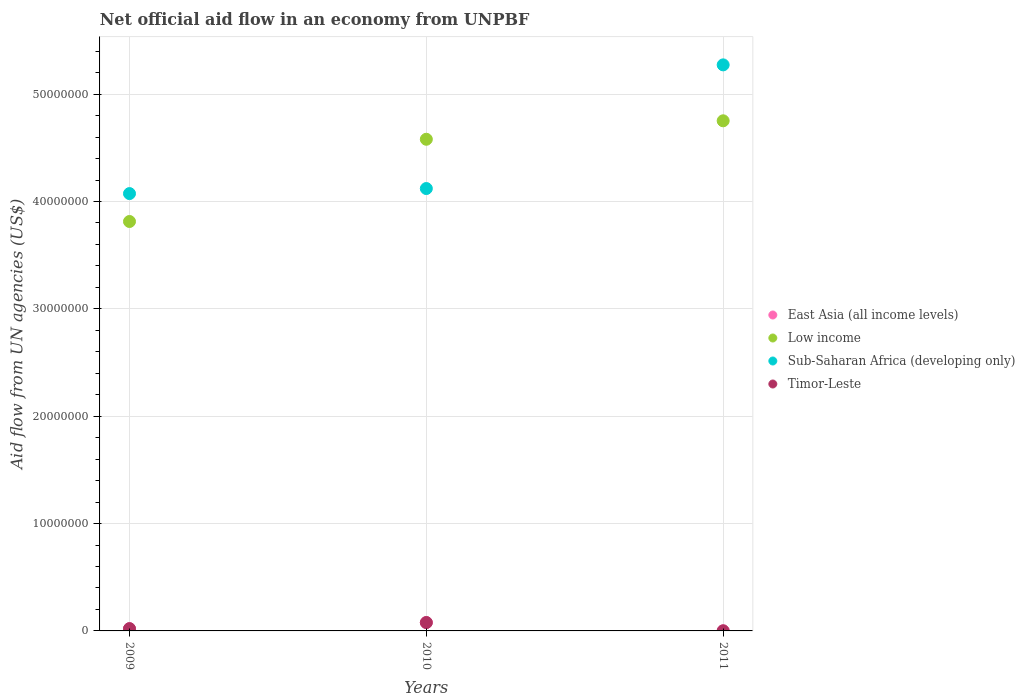How many different coloured dotlines are there?
Provide a short and direct response. 4. Is the number of dotlines equal to the number of legend labels?
Give a very brief answer. Yes. What is the net official aid flow in Sub-Saharan Africa (developing only) in 2009?
Make the answer very short. 4.07e+07. Across all years, what is the maximum net official aid flow in Low income?
Your answer should be very brief. 4.75e+07. Across all years, what is the minimum net official aid flow in Low income?
Keep it short and to the point. 3.81e+07. What is the difference between the net official aid flow in Sub-Saharan Africa (developing only) in 2010 and that in 2011?
Make the answer very short. -1.15e+07. What is the difference between the net official aid flow in Sub-Saharan Africa (developing only) in 2009 and the net official aid flow in Timor-Leste in 2010?
Make the answer very short. 4.00e+07. What is the average net official aid flow in East Asia (all income levels) per year?
Your response must be concise. 3.33e+05. In the year 2010, what is the difference between the net official aid flow in Low income and net official aid flow in Timor-Leste?
Your response must be concise. 4.50e+07. In how many years, is the net official aid flow in East Asia (all income levels) greater than 44000000 US$?
Give a very brief answer. 0. Is the net official aid flow in Timor-Leste in 2010 less than that in 2011?
Your answer should be very brief. No. Is the difference between the net official aid flow in Low income in 2010 and 2011 greater than the difference between the net official aid flow in Timor-Leste in 2010 and 2011?
Ensure brevity in your answer.  No. What is the difference between the highest and the second highest net official aid flow in Low income?
Provide a succinct answer. 1.72e+06. What is the difference between the highest and the lowest net official aid flow in East Asia (all income levels)?
Keep it short and to the point. 7.70e+05. Is the sum of the net official aid flow in East Asia (all income levels) in 2009 and 2011 greater than the maximum net official aid flow in Sub-Saharan Africa (developing only) across all years?
Your response must be concise. No. Is it the case that in every year, the sum of the net official aid flow in East Asia (all income levels) and net official aid flow in Low income  is greater than the sum of net official aid flow in Sub-Saharan Africa (developing only) and net official aid flow in Timor-Leste?
Offer a very short reply. Yes. Is it the case that in every year, the sum of the net official aid flow in East Asia (all income levels) and net official aid flow in Sub-Saharan Africa (developing only)  is greater than the net official aid flow in Low income?
Make the answer very short. No. Does the net official aid flow in Low income monotonically increase over the years?
Offer a terse response. Yes. Is the net official aid flow in East Asia (all income levels) strictly greater than the net official aid flow in Timor-Leste over the years?
Keep it short and to the point. No. Is the net official aid flow in Timor-Leste strictly less than the net official aid flow in East Asia (all income levels) over the years?
Provide a short and direct response. No. How many years are there in the graph?
Your response must be concise. 3. What is the difference between two consecutive major ticks on the Y-axis?
Offer a very short reply. 1.00e+07. Does the graph contain any zero values?
Keep it short and to the point. No. Does the graph contain grids?
Make the answer very short. Yes. What is the title of the graph?
Ensure brevity in your answer.  Net official aid flow in an economy from UNPBF. Does "Estonia" appear as one of the legend labels in the graph?
Ensure brevity in your answer.  No. What is the label or title of the X-axis?
Provide a succinct answer. Years. What is the label or title of the Y-axis?
Make the answer very short. Aid flow from UN agencies (US$). What is the Aid flow from UN agencies (US$) of Low income in 2009?
Provide a succinct answer. 3.81e+07. What is the Aid flow from UN agencies (US$) of Sub-Saharan Africa (developing only) in 2009?
Provide a short and direct response. 4.07e+07. What is the Aid flow from UN agencies (US$) in Timor-Leste in 2009?
Provide a succinct answer. 2.10e+05. What is the Aid flow from UN agencies (US$) of East Asia (all income levels) in 2010?
Offer a very short reply. 7.80e+05. What is the Aid flow from UN agencies (US$) in Low income in 2010?
Give a very brief answer. 4.58e+07. What is the Aid flow from UN agencies (US$) of Sub-Saharan Africa (developing only) in 2010?
Your response must be concise. 4.12e+07. What is the Aid flow from UN agencies (US$) in Timor-Leste in 2010?
Keep it short and to the point. 7.80e+05. What is the Aid flow from UN agencies (US$) in Low income in 2011?
Your answer should be very brief. 4.75e+07. What is the Aid flow from UN agencies (US$) of Sub-Saharan Africa (developing only) in 2011?
Your response must be concise. 5.27e+07. What is the Aid flow from UN agencies (US$) in Timor-Leste in 2011?
Your answer should be compact. 10000. Across all years, what is the maximum Aid flow from UN agencies (US$) of East Asia (all income levels)?
Ensure brevity in your answer.  7.80e+05. Across all years, what is the maximum Aid flow from UN agencies (US$) in Low income?
Provide a short and direct response. 4.75e+07. Across all years, what is the maximum Aid flow from UN agencies (US$) in Sub-Saharan Africa (developing only)?
Provide a short and direct response. 5.27e+07. Across all years, what is the maximum Aid flow from UN agencies (US$) of Timor-Leste?
Ensure brevity in your answer.  7.80e+05. Across all years, what is the minimum Aid flow from UN agencies (US$) of Low income?
Keep it short and to the point. 3.81e+07. Across all years, what is the minimum Aid flow from UN agencies (US$) in Sub-Saharan Africa (developing only)?
Keep it short and to the point. 4.07e+07. What is the total Aid flow from UN agencies (US$) of East Asia (all income levels) in the graph?
Your response must be concise. 1.00e+06. What is the total Aid flow from UN agencies (US$) of Low income in the graph?
Your answer should be very brief. 1.31e+08. What is the total Aid flow from UN agencies (US$) of Sub-Saharan Africa (developing only) in the graph?
Give a very brief answer. 1.35e+08. What is the difference between the Aid flow from UN agencies (US$) in East Asia (all income levels) in 2009 and that in 2010?
Give a very brief answer. -5.70e+05. What is the difference between the Aid flow from UN agencies (US$) in Low income in 2009 and that in 2010?
Make the answer very short. -7.66e+06. What is the difference between the Aid flow from UN agencies (US$) of Sub-Saharan Africa (developing only) in 2009 and that in 2010?
Make the answer very short. -4.70e+05. What is the difference between the Aid flow from UN agencies (US$) of Timor-Leste in 2009 and that in 2010?
Keep it short and to the point. -5.70e+05. What is the difference between the Aid flow from UN agencies (US$) of East Asia (all income levels) in 2009 and that in 2011?
Your answer should be compact. 2.00e+05. What is the difference between the Aid flow from UN agencies (US$) of Low income in 2009 and that in 2011?
Your answer should be very brief. -9.38e+06. What is the difference between the Aid flow from UN agencies (US$) of Sub-Saharan Africa (developing only) in 2009 and that in 2011?
Your response must be concise. -1.20e+07. What is the difference between the Aid flow from UN agencies (US$) in Timor-Leste in 2009 and that in 2011?
Keep it short and to the point. 2.00e+05. What is the difference between the Aid flow from UN agencies (US$) of East Asia (all income levels) in 2010 and that in 2011?
Ensure brevity in your answer.  7.70e+05. What is the difference between the Aid flow from UN agencies (US$) of Low income in 2010 and that in 2011?
Your answer should be compact. -1.72e+06. What is the difference between the Aid flow from UN agencies (US$) in Sub-Saharan Africa (developing only) in 2010 and that in 2011?
Provide a short and direct response. -1.15e+07. What is the difference between the Aid flow from UN agencies (US$) of Timor-Leste in 2010 and that in 2011?
Offer a very short reply. 7.70e+05. What is the difference between the Aid flow from UN agencies (US$) of East Asia (all income levels) in 2009 and the Aid flow from UN agencies (US$) of Low income in 2010?
Your answer should be very brief. -4.56e+07. What is the difference between the Aid flow from UN agencies (US$) in East Asia (all income levels) in 2009 and the Aid flow from UN agencies (US$) in Sub-Saharan Africa (developing only) in 2010?
Keep it short and to the point. -4.10e+07. What is the difference between the Aid flow from UN agencies (US$) of East Asia (all income levels) in 2009 and the Aid flow from UN agencies (US$) of Timor-Leste in 2010?
Offer a very short reply. -5.70e+05. What is the difference between the Aid flow from UN agencies (US$) in Low income in 2009 and the Aid flow from UN agencies (US$) in Sub-Saharan Africa (developing only) in 2010?
Offer a terse response. -3.07e+06. What is the difference between the Aid flow from UN agencies (US$) of Low income in 2009 and the Aid flow from UN agencies (US$) of Timor-Leste in 2010?
Your answer should be compact. 3.74e+07. What is the difference between the Aid flow from UN agencies (US$) in Sub-Saharan Africa (developing only) in 2009 and the Aid flow from UN agencies (US$) in Timor-Leste in 2010?
Provide a short and direct response. 4.00e+07. What is the difference between the Aid flow from UN agencies (US$) in East Asia (all income levels) in 2009 and the Aid flow from UN agencies (US$) in Low income in 2011?
Ensure brevity in your answer.  -4.73e+07. What is the difference between the Aid flow from UN agencies (US$) of East Asia (all income levels) in 2009 and the Aid flow from UN agencies (US$) of Sub-Saharan Africa (developing only) in 2011?
Your answer should be compact. -5.25e+07. What is the difference between the Aid flow from UN agencies (US$) of Low income in 2009 and the Aid flow from UN agencies (US$) of Sub-Saharan Africa (developing only) in 2011?
Provide a short and direct response. -1.46e+07. What is the difference between the Aid flow from UN agencies (US$) of Low income in 2009 and the Aid flow from UN agencies (US$) of Timor-Leste in 2011?
Give a very brief answer. 3.81e+07. What is the difference between the Aid flow from UN agencies (US$) of Sub-Saharan Africa (developing only) in 2009 and the Aid flow from UN agencies (US$) of Timor-Leste in 2011?
Your answer should be very brief. 4.07e+07. What is the difference between the Aid flow from UN agencies (US$) in East Asia (all income levels) in 2010 and the Aid flow from UN agencies (US$) in Low income in 2011?
Keep it short and to the point. -4.67e+07. What is the difference between the Aid flow from UN agencies (US$) of East Asia (all income levels) in 2010 and the Aid flow from UN agencies (US$) of Sub-Saharan Africa (developing only) in 2011?
Ensure brevity in your answer.  -5.20e+07. What is the difference between the Aid flow from UN agencies (US$) of East Asia (all income levels) in 2010 and the Aid flow from UN agencies (US$) of Timor-Leste in 2011?
Offer a very short reply. 7.70e+05. What is the difference between the Aid flow from UN agencies (US$) of Low income in 2010 and the Aid flow from UN agencies (US$) of Sub-Saharan Africa (developing only) in 2011?
Keep it short and to the point. -6.93e+06. What is the difference between the Aid flow from UN agencies (US$) in Low income in 2010 and the Aid flow from UN agencies (US$) in Timor-Leste in 2011?
Provide a short and direct response. 4.58e+07. What is the difference between the Aid flow from UN agencies (US$) of Sub-Saharan Africa (developing only) in 2010 and the Aid flow from UN agencies (US$) of Timor-Leste in 2011?
Your answer should be compact. 4.12e+07. What is the average Aid flow from UN agencies (US$) of East Asia (all income levels) per year?
Offer a very short reply. 3.33e+05. What is the average Aid flow from UN agencies (US$) in Low income per year?
Keep it short and to the point. 4.38e+07. What is the average Aid flow from UN agencies (US$) of Sub-Saharan Africa (developing only) per year?
Provide a short and direct response. 4.49e+07. What is the average Aid flow from UN agencies (US$) of Timor-Leste per year?
Your answer should be compact. 3.33e+05. In the year 2009, what is the difference between the Aid flow from UN agencies (US$) of East Asia (all income levels) and Aid flow from UN agencies (US$) of Low income?
Keep it short and to the point. -3.79e+07. In the year 2009, what is the difference between the Aid flow from UN agencies (US$) in East Asia (all income levels) and Aid flow from UN agencies (US$) in Sub-Saharan Africa (developing only)?
Your answer should be compact. -4.05e+07. In the year 2009, what is the difference between the Aid flow from UN agencies (US$) in East Asia (all income levels) and Aid flow from UN agencies (US$) in Timor-Leste?
Make the answer very short. 0. In the year 2009, what is the difference between the Aid flow from UN agencies (US$) of Low income and Aid flow from UN agencies (US$) of Sub-Saharan Africa (developing only)?
Offer a very short reply. -2.60e+06. In the year 2009, what is the difference between the Aid flow from UN agencies (US$) in Low income and Aid flow from UN agencies (US$) in Timor-Leste?
Your answer should be very brief. 3.79e+07. In the year 2009, what is the difference between the Aid flow from UN agencies (US$) in Sub-Saharan Africa (developing only) and Aid flow from UN agencies (US$) in Timor-Leste?
Ensure brevity in your answer.  4.05e+07. In the year 2010, what is the difference between the Aid flow from UN agencies (US$) in East Asia (all income levels) and Aid flow from UN agencies (US$) in Low income?
Your answer should be very brief. -4.50e+07. In the year 2010, what is the difference between the Aid flow from UN agencies (US$) in East Asia (all income levels) and Aid flow from UN agencies (US$) in Sub-Saharan Africa (developing only)?
Your answer should be compact. -4.04e+07. In the year 2010, what is the difference between the Aid flow from UN agencies (US$) in Low income and Aid flow from UN agencies (US$) in Sub-Saharan Africa (developing only)?
Give a very brief answer. 4.59e+06. In the year 2010, what is the difference between the Aid flow from UN agencies (US$) in Low income and Aid flow from UN agencies (US$) in Timor-Leste?
Keep it short and to the point. 4.50e+07. In the year 2010, what is the difference between the Aid flow from UN agencies (US$) of Sub-Saharan Africa (developing only) and Aid flow from UN agencies (US$) of Timor-Leste?
Provide a short and direct response. 4.04e+07. In the year 2011, what is the difference between the Aid flow from UN agencies (US$) in East Asia (all income levels) and Aid flow from UN agencies (US$) in Low income?
Make the answer very short. -4.75e+07. In the year 2011, what is the difference between the Aid flow from UN agencies (US$) of East Asia (all income levels) and Aid flow from UN agencies (US$) of Sub-Saharan Africa (developing only)?
Ensure brevity in your answer.  -5.27e+07. In the year 2011, what is the difference between the Aid flow from UN agencies (US$) in East Asia (all income levels) and Aid flow from UN agencies (US$) in Timor-Leste?
Your response must be concise. 0. In the year 2011, what is the difference between the Aid flow from UN agencies (US$) in Low income and Aid flow from UN agencies (US$) in Sub-Saharan Africa (developing only)?
Give a very brief answer. -5.21e+06. In the year 2011, what is the difference between the Aid flow from UN agencies (US$) in Low income and Aid flow from UN agencies (US$) in Timor-Leste?
Your answer should be compact. 4.75e+07. In the year 2011, what is the difference between the Aid flow from UN agencies (US$) in Sub-Saharan Africa (developing only) and Aid flow from UN agencies (US$) in Timor-Leste?
Give a very brief answer. 5.27e+07. What is the ratio of the Aid flow from UN agencies (US$) of East Asia (all income levels) in 2009 to that in 2010?
Keep it short and to the point. 0.27. What is the ratio of the Aid flow from UN agencies (US$) of Low income in 2009 to that in 2010?
Ensure brevity in your answer.  0.83. What is the ratio of the Aid flow from UN agencies (US$) of Timor-Leste in 2009 to that in 2010?
Ensure brevity in your answer.  0.27. What is the ratio of the Aid flow from UN agencies (US$) in East Asia (all income levels) in 2009 to that in 2011?
Offer a terse response. 21. What is the ratio of the Aid flow from UN agencies (US$) of Low income in 2009 to that in 2011?
Offer a terse response. 0.8. What is the ratio of the Aid flow from UN agencies (US$) of Sub-Saharan Africa (developing only) in 2009 to that in 2011?
Provide a short and direct response. 0.77. What is the ratio of the Aid flow from UN agencies (US$) of East Asia (all income levels) in 2010 to that in 2011?
Provide a succinct answer. 78. What is the ratio of the Aid flow from UN agencies (US$) in Low income in 2010 to that in 2011?
Ensure brevity in your answer.  0.96. What is the ratio of the Aid flow from UN agencies (US$) of Sub-Saharan Africa (developing only) in 2010 to that in 2011?
Offer a very short reply. 0.78. What is the ratio of the Aid flow from UN agencies (US$) of Timor-Leste in 2010 to that in 2011?
Make the answer very short. 78. What is the difference between the highest and the second highest Aid flow from UN agencies (US$) of East Asia (all income levels)?
Provide a short and direct response. 5.70e+05. What is the difference between the highest and the second highest Aid flow from UN agencies (US$) of Low income?
Provide a succinct answer. 1.72e+06. What is the difference between the highest and the second highest Aid flow from UN agencies (US$) of Sub-Saharan Africa (developing only)?
Provide a short and direct response. 1.15e+07. What is the difference between the highest and the second highest Aid flow from UN agencies (US$) in Timor-Leste?
Give a very brief answer. 5.70e+05. What is the difference between the highest and the lowest Aid flow from UN agencies (US$) in East Asia (all income levels)?
Provide a short and direct response. 7.70e+05. What is the difference between the highest and the lowest Aid flow from UN agencies (US$) in Low income?
Make the answer very short. 9.38e+06. What is the difference between the highest and the lowest Aid flow from UN agencies (US$) of Sub-Saharan Africa (developing only)?
Offer a very short reply. 1.20e+07. What is the difference between the highest and the lowest Aid flow from UN agencies (US$) of Timor-Leste?
Keep it short and to the point. 7.70e+05. 